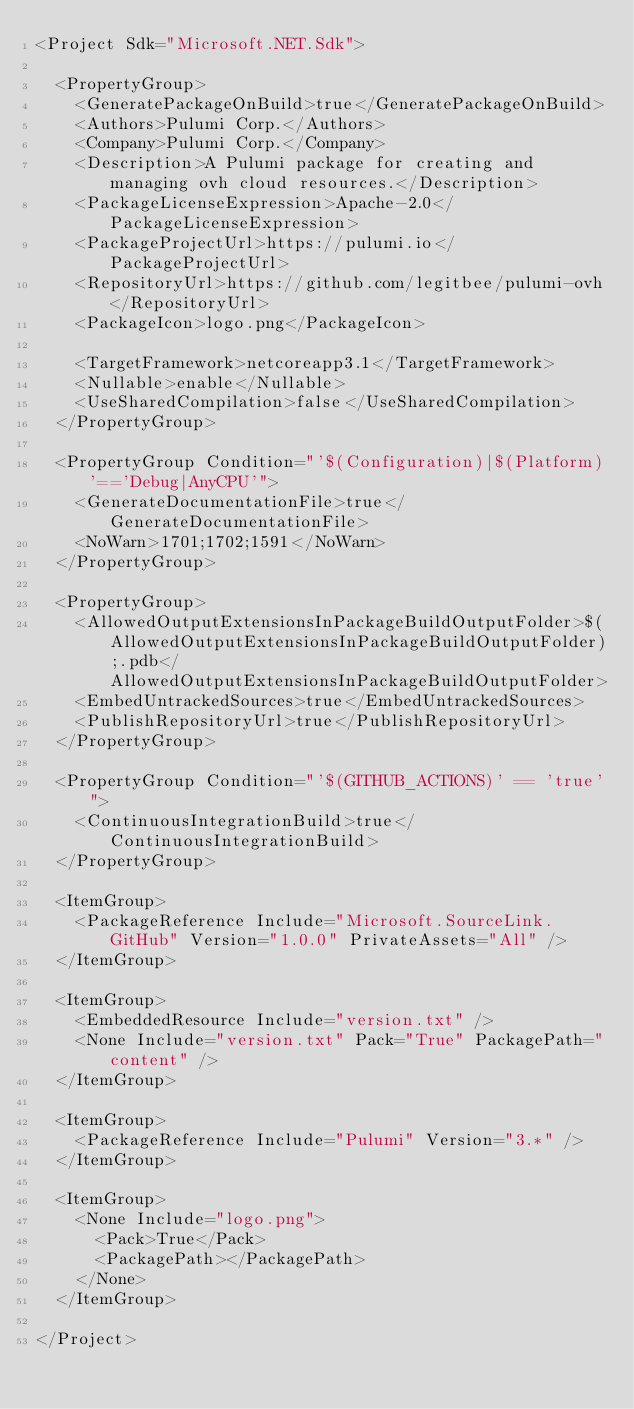Convert code to text. <code><loc_0><loc_0><loc_500><loc_500><_XML_><Project Sdk="Microsoft.NET.Sdk">

  <PropertyGroup>
    <GeneratePackageOnBuild>true</GeneratePackageOnBuild>
    <Authors>Pulumi Corp.</Authors>
    <Company>Pulumi Corp.</Company>
    <Description>A Pulumi package for creating and managing ovh cloud resources.</Description>
    <PackageLicenseExpression>Apache-2.0</PackageLicenseExpression>
    <PackageProjectUrl>https://pulumi.io</PackageProjectUrl>
    <RepositoryUrl>https://github.com/legitbee/pulumi-ovh</RepositoryUrl>
    <PackageIcon>logo.png</PackageIcon>

    <TargetFramework>netcoreapp3.1</TargetFramework>
    <Nullable>enable</Nullable>
    <UseSharedCompilation>false</UseSharedCompilation>
  </PropertyGroup>

  <PropertyGroup Condition="'$(Configuration)|$(Platform)'=='Debug|AnyCPU'">
    <GenerateDocumentationFile>true</GenerateDocumentationFile>
    <NoWarn>1701;1702;1591</NoWarn>
  </PropertyGroup>

  <PropertyGroup>
    <AllowedOutputExtensionsInPackageBuildOutputFolder>$(AllowedOutputExtensionsInPackageBuildOutputFolder);.pdb</AllowedOutputExtensionsInPackageBuildOutputFolder>
    <EmbedUntrackedSources>true</EmbedUntrackedSources>
    <PublishRepositoryUrl>true</PublishRepositoryUrl>
  </PropertyGroup>

  <PropertyGroup Condition="'$(GITHUB_ACTIONS)' == 'true'">
    <ContinuousIntegrationBuild>true</ContinuousIntegrationBuild>
  </PropertyGroup>

  <ItemGroup>
    <PackageReference Include="Microsoft.SourceLink.GitHub" Version="1.0.0" PrivateAssets="All" />
  </ItemGroup>

  <ItemGroup>
    <EmbeddedResource Include="version.txt" />
    <None Include="version.txt" Pack="True" PackagePath="content" />
  </ItemGroup>

  <ItemGroup>
    <PackageReference Include="Pulumi" Version="3.*" />
  </ItemGroup>

  <ItemGroup>
    <None Include="logo.png">
      <Pack>True</Pack>
      <PackagePath></PackagePath>
    </None>
  </ItemGroup>

</Project>
</code> 